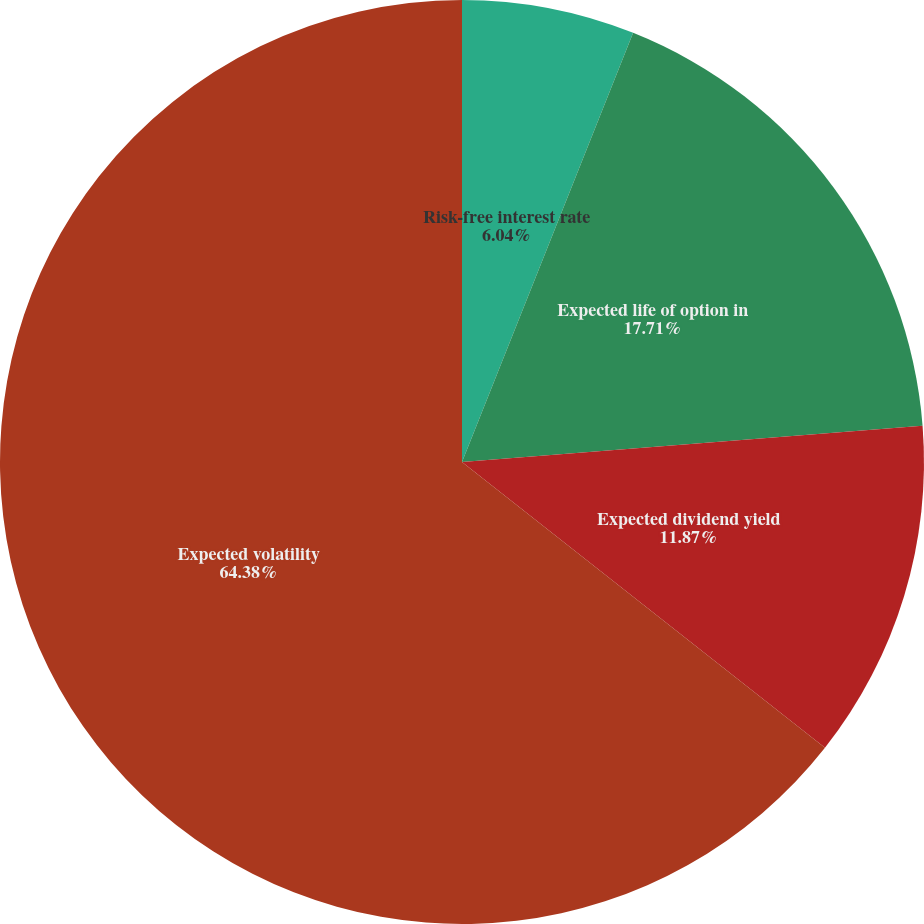Convert chart to OTSL. <chart><loc_0><loc_0><loc_500><loc_500><pie_chart><fcel>Risk-free interest rate<fcel>Expected life of option in<fcel>Expected dividend yield<fcel>Expected volatility<nl><fcel>6.04%<fcel>17.71%<fcel>11.87%<fcel>64.39%<nl></chart> 